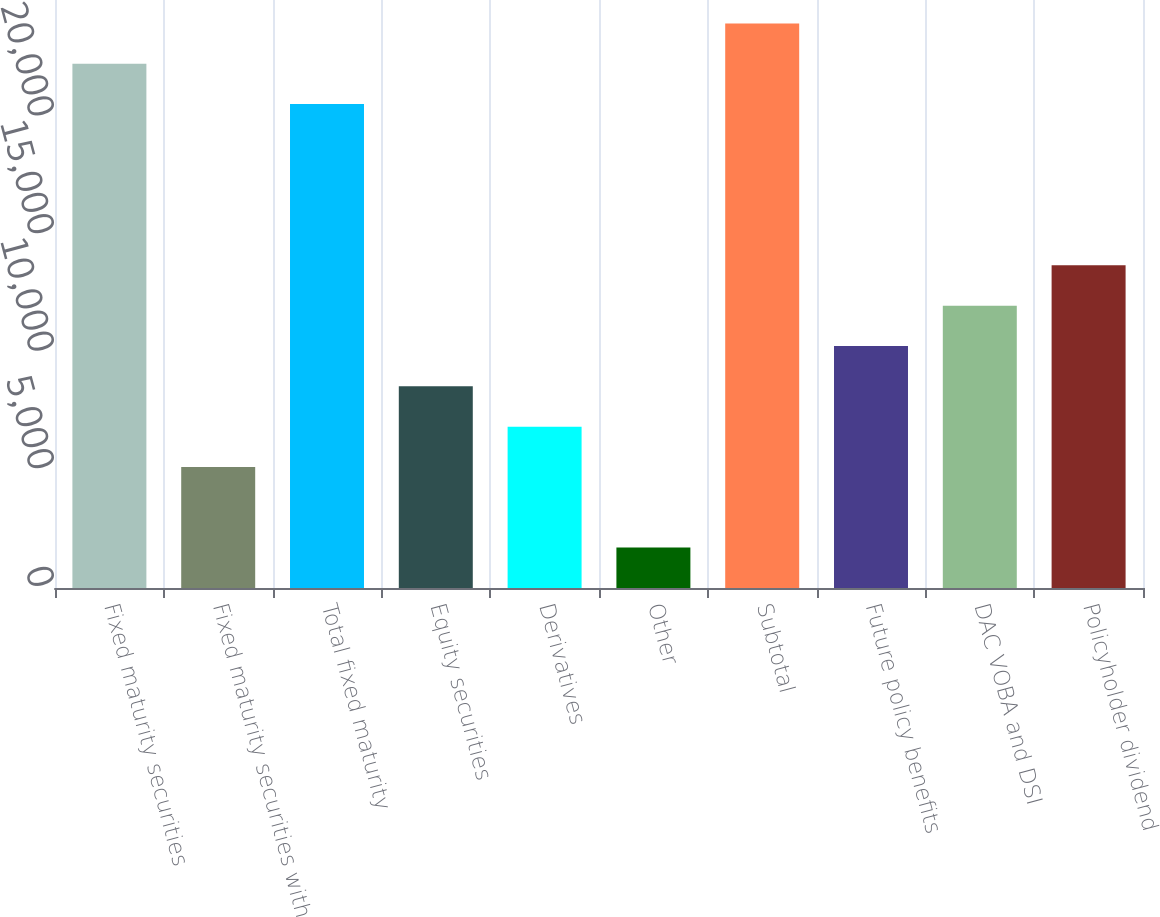Convert chart to OTSL. <chart><loc_0><loc_0><loc_500><loc_500><bar_chart><fcel>Fixed maturity securities<fcel>Fixed maturity securities with<fcel>Total fixed maturity<fcel>Equity securities<fcel>Derivatives<fcel>Other<fcel>Subtotal<fcel>Future policy benefits<fcel>DAC VOBA and DSI<fcel>Policyholder dividend<nl><fcel>22288.6<fcel>5146.6<fcel>20574.4<fcel>8575<fcel>6860.8<fcel>1718.2<fcel>24002.8<fcel>10289.2<fcel>12003.4<fcel>13717.6<nl></chart> 